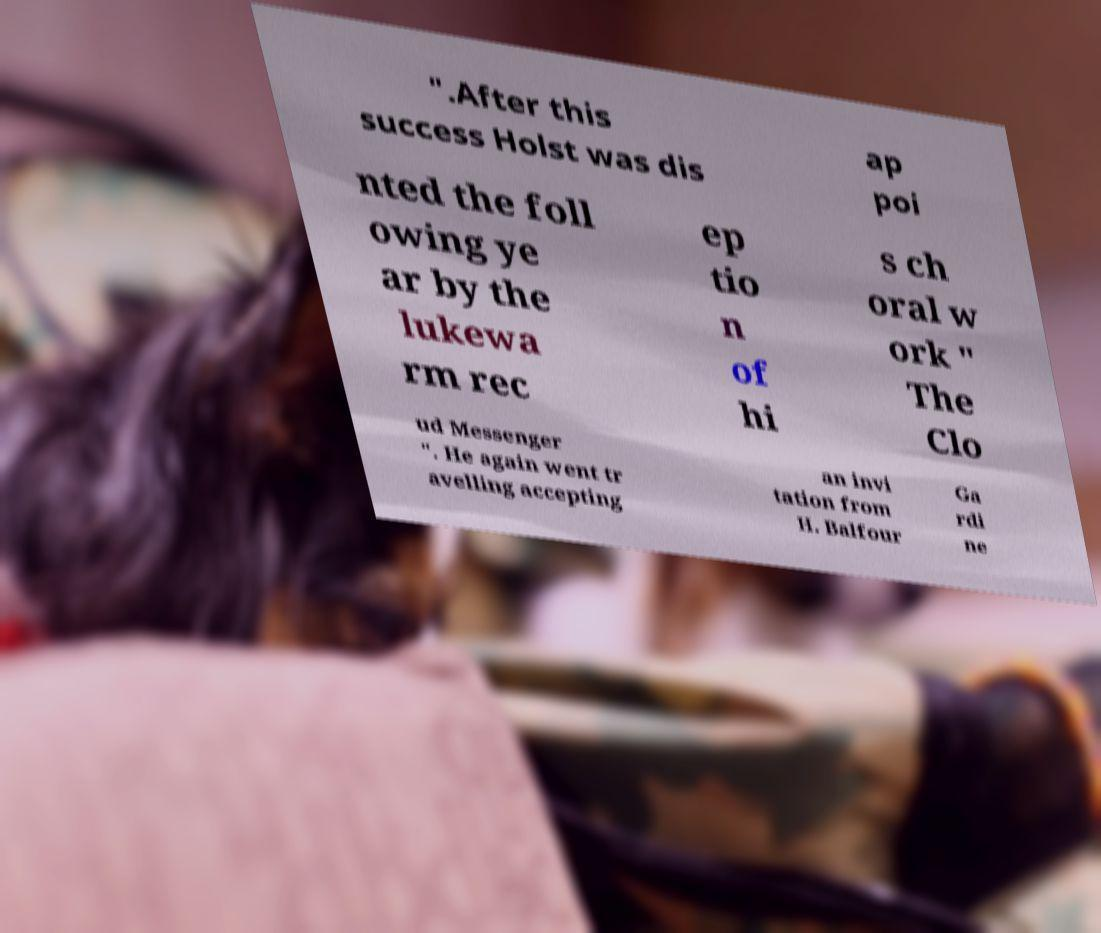Could you assist in decoding the text presented in this image and type it out clearly? ".After this success Holst was dis ap poi nted the foll owing ye ar by the lukewa rm rec ep tio n of hi s ch oral w ork " The Clo ud Messenger ". He again went tr avelling accepting an invi tation from H. Balfour Ga rdi ne 